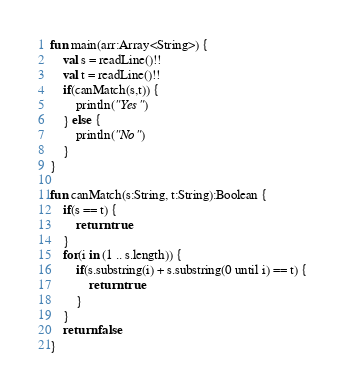<code> <loc_0><loc_0><loc_500><loc_500><_Kotlin_>fun main(arr:Array<String>) {
    val s = readLine()!!
    val t = readLine()!!
    if(canMatch(s,t)) {
        println("Yes")
    } else {
        println("No")
    }
}

fun canMatch(s:String, t:String):Boolean {
    if(s == t) {
        return true
    }
    for(i in (1 .. s.length)) {
        if(s.substring(i) + s.substring(0 until i) == t) {
            return true
        }
    }
    return false
}</code> 